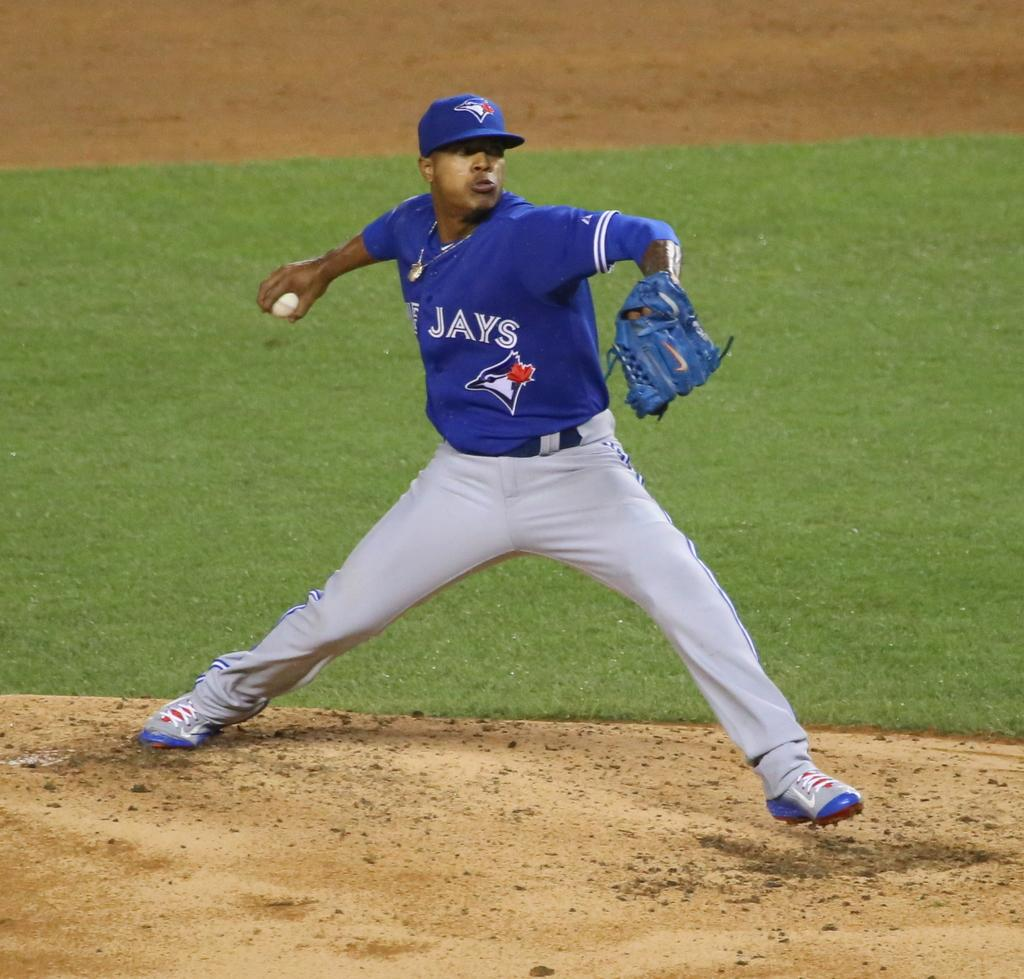<image>
Give a short and clear explanation of the subsequent image. The Jays pitcher is about to throw the baseball. 